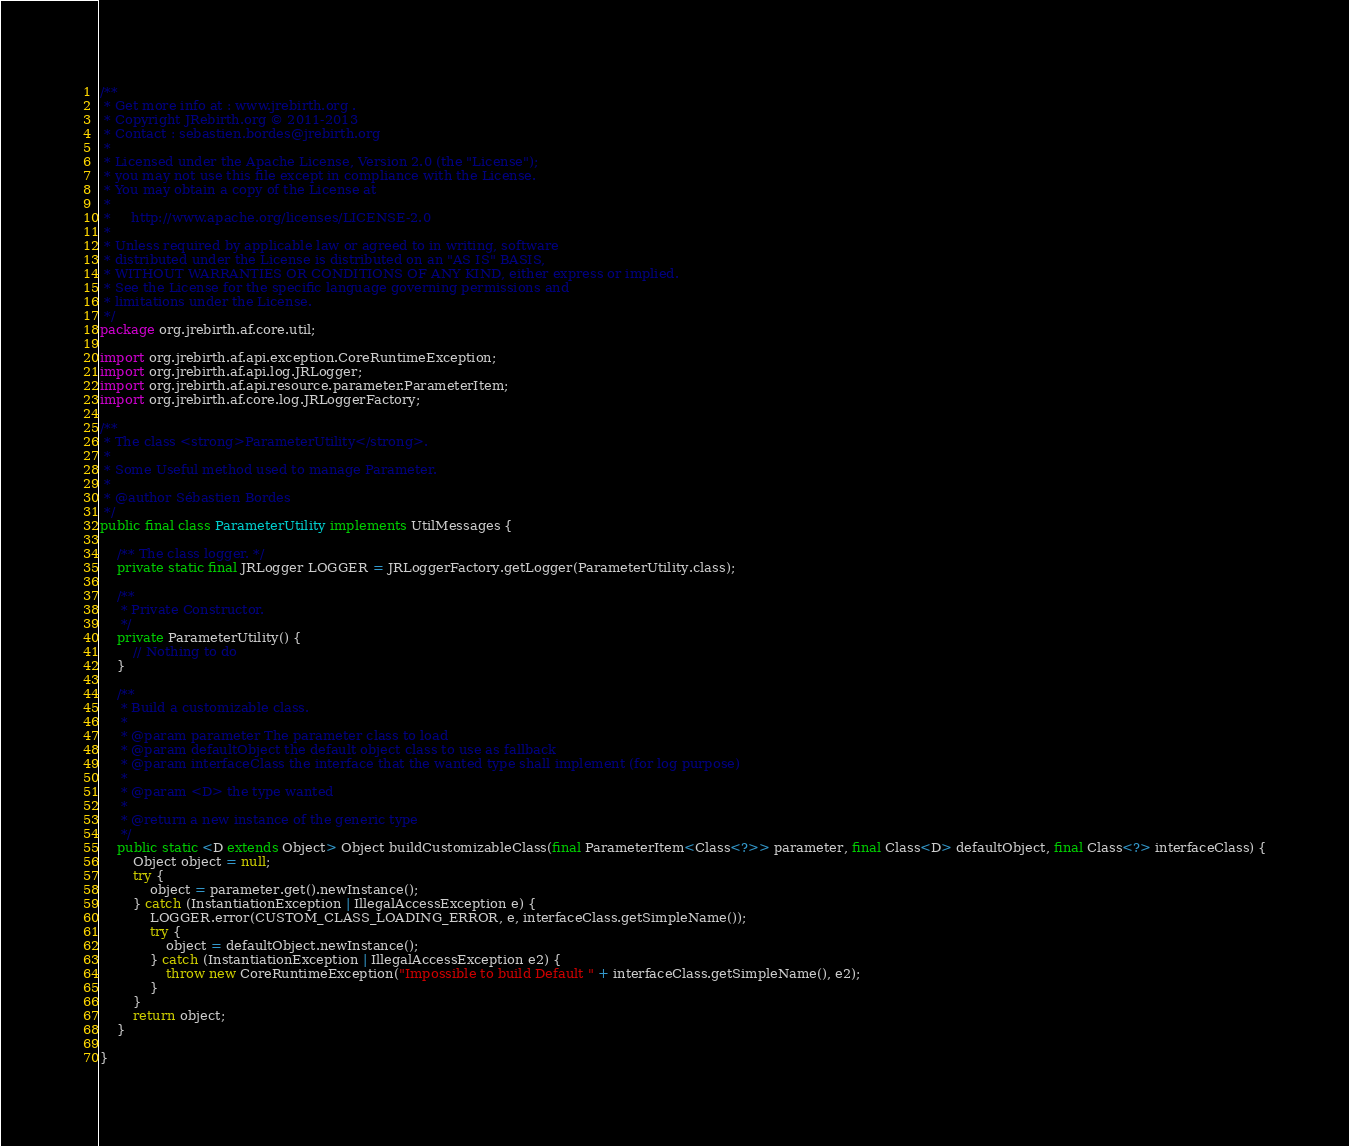<code> <loc_0><loc_0><loc_500><loc_500><_Java_>/**
 * Get more info at : www.jrebirth.org .
 * Copyright JRebirth.org © 2011-2013
 * Contact : sebastien.bordes@jrebirth.org
 *
 * Licensed under the Apache License, Version 2.0 (the "License");
 * you may not use this file except in compliance with the License.
 * You may obtain a copy of the License at
 *
 *     http://www.apache.org/licenses/LICENSE-2.0
 *
 * Unless required by applicable law or agreed to in writing, software
 * distributed under the License is distributed on an "AS IS" BASIS,
 * WITHOUT WARRANTIES OR CONDITIONS OF ANY KIND, either express or implied.
 * See the License for the specific language governing permissions and
 * limitations under the License.
 */
package org.jrebirth.af.core.util;

import org.jrebirth.af.api.exception.CoreRuntimeException;
import org.jrebirth.af.api.log.JRLogger;
import org.jrebirth.af.api.resource.parameter.ParameterItem;
import org.jrebirth.af.core.log.JRLoggerFactory;

/**
 * The class <strong>ParameterUtility</strong>.
 *
 * Some Useful method used to manage Parameter.
 *
 * @author Sébastien Bordes
 */
public final class ParameterUtility implements UtilMessages {

    /** The class logger. */
    private static final JRLogger LOGGER = JRLoggerFactory.getLogger(ParameterUtility.class);

    /**
     * Private Constructor.
     */
    private ParameterUtility() {
        // Nothing to do
    }

    /**
     * Build a customizable class.
     *
     * @param parameter The parameter class to load
     * @param defaultObject the default object class to use as fallback
     * @param interfaceClass the interface that the wanted type shall implement (for log purpose)
     *
     * @param <D> the type wanted
     *
     * @return a new instance of the generic type
     */
    public static <D extends Object> Object buildCustomizableClass(final ParameterItem<Class<?>> parameter, final Class<D> defaultObject, final Class<?> interfaceClass) {
        Object object = null;
        try {
            object = parameter.get().newInstance();
        } catch (InstantiationException | IllegalAccessException e) {
            LOGGER.error(CUSTOM_CLASS_LOADING_ERROR, e, interfaceClass.getSimpleName());
            try {
                object = defaultObject.newInstance();
            } catch (InstantiationException | IllegalAccessException e2) {
                throw new CoreRuntimeException("Impossible to build Default " + interfaceClass.getSimpleName(), e2);
            }
        }
        return object;
    }

}
</code> 